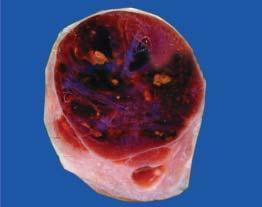what shows lobules of translucent gelatinous light brown parenchyma and areas of haemorrhage?
Answer the question using a single word or phrase. Cut section 